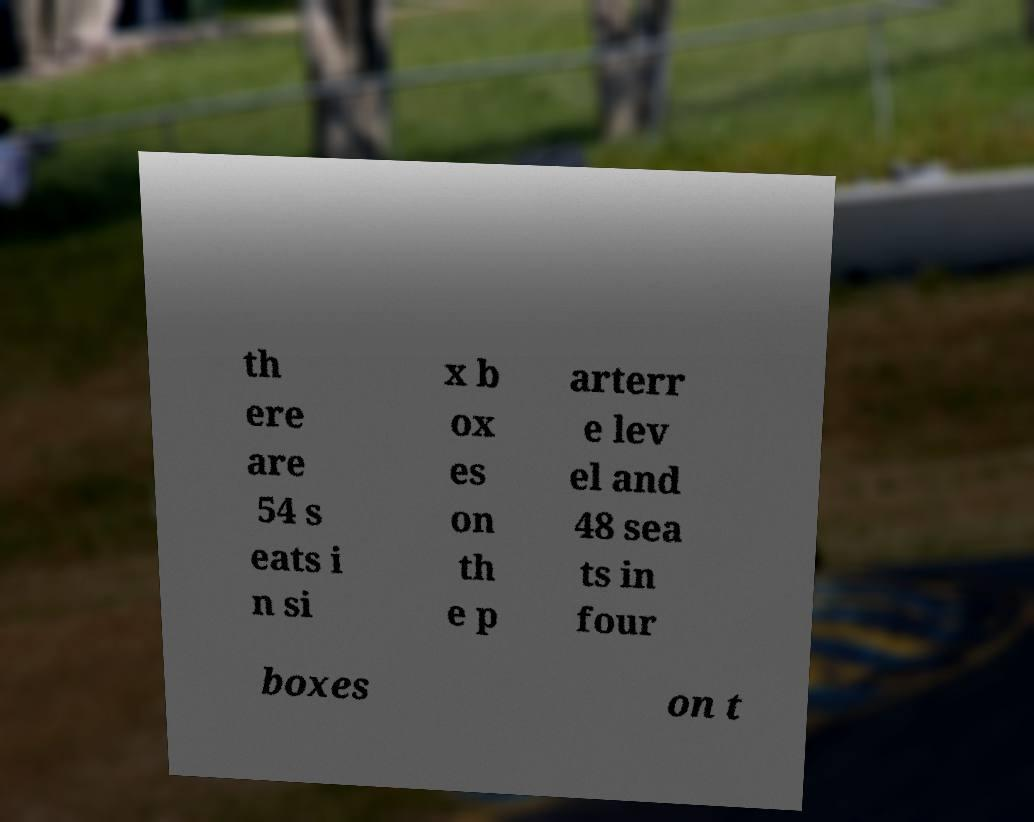Please read and relay the text visible in this image. What does it say? th ere are 54 s eats i n si x b ox es on th e p arterr e lev el and 48 sea ts in four boxes on t 